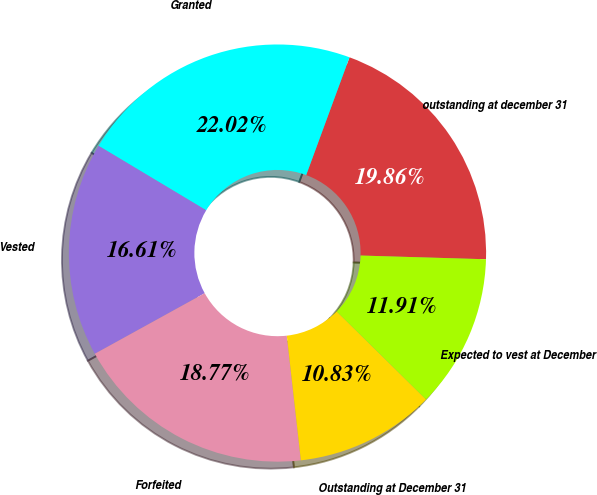<chart> <loc_0><loc_0><loc_500><loc_500><pie_chart><fcel>outstanding at december 31<fcel>Granted<fcel>Vested<fcel>Forfeited<fcel>Outstanding at December 31<fcel>Expected to vest at December<nl><fcel>19.86%<fcel>22.02%<fcel>16.61%<fcel>18.77%<fcel>10.83%<fcel>11.91%<nl></chart> 